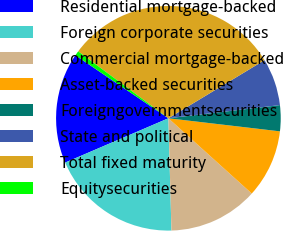<chart> <loc_0><loc_0><loc_500><loc_500><pie_chart><fcel>Residential mortgage-backed<fcel>Foreign corporate securities<fcel>Commercial mortgage-backed<fcel>Asset-backed securities<fcel>Foreigngovernmentsecurities<fcel>State and political<fcel>Total fixed maturity<fcel>Equitysecurities<nl><fcel>15.93%<fcel>18.98%<fcel>12.88%<fcel>9.83%<fcel>3.73%<fcel>6.78%<fcel>31.19%<fcel>0.68%<nl></chart> 